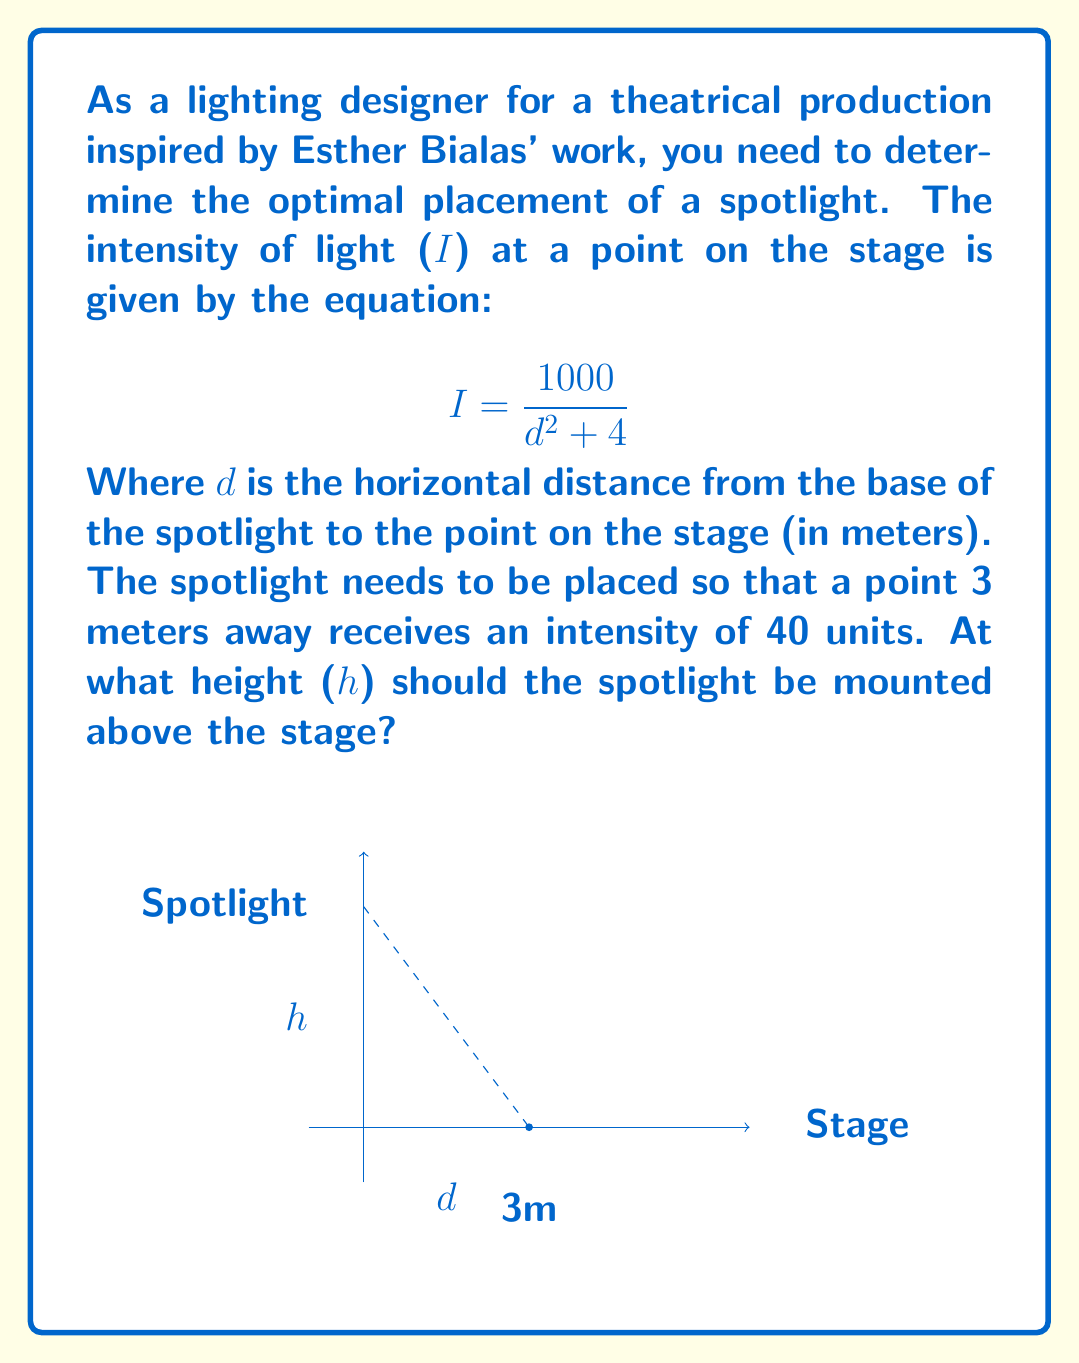Solve this math problem. Let's approach this step-by-step:

1) We know that the intensity at a point 3 meters away horizontally is 40 units. Let's plug this into our equation:

   $$40 = \frac{1000}{3^2 + 4}$$

2) Now, we need to solve for the height (h) of the spotlight. We can use the Pythagorean theorem to relate d, h, and the actual distance from the spotlight to the point:

   $$d^2 + h^2 = 3^2 + h^2$$

3) Substituting this into our original equation:

   $$40 = \frac{1000}{(3^2 + h^2) + 4}$$

4) Simplify:
   
   $$40 = \frac{1000}{9 + h^2 + 4} = \frac{1000}{13 + h^2}$$

5) Multiply both sides by $(13 + h^2)$:

   $$40(13 + h^2) = 1000$$

6) Expand:

   $$520 + 40h^2 = 1000$$

7) Subtract 520 from both sides:

   $$40h^2 = 480$$

8) Divide both sides by 40:

   $$h^2 = 12$$

9) Take the square root of both sides:

   $$h = \sqrt{12} = 2\sqrt{3}$$

Therefore, the spotlight should be mounted at a height of $2\sqrt{3}$ meters above the stage.
Answer: $2\sqrt{3}$ meters 